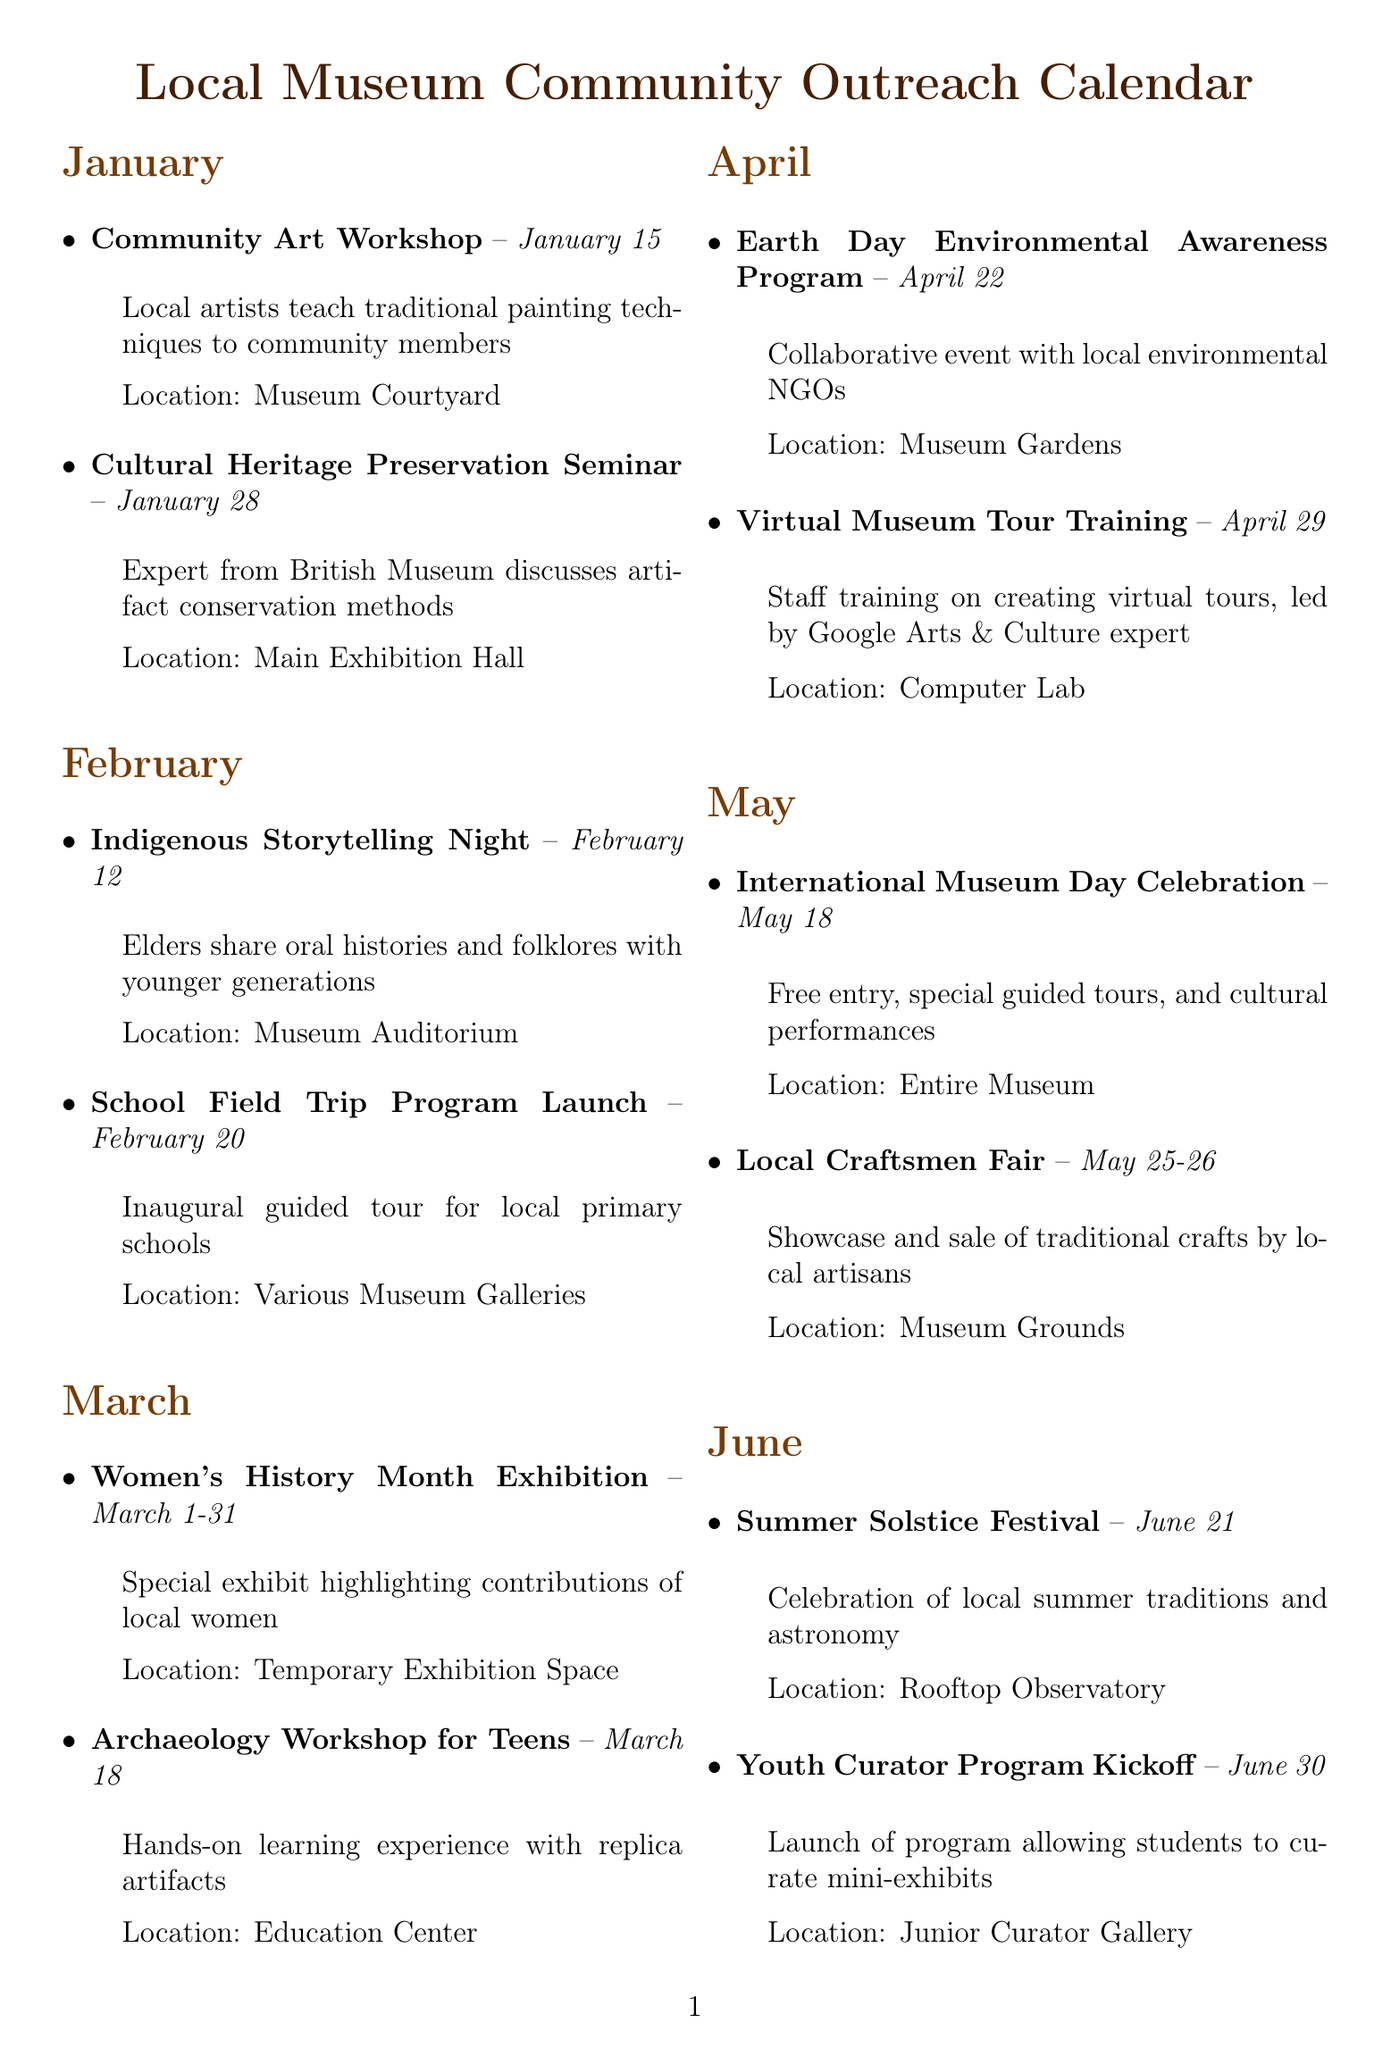What event occurs on February 12? The event on February 12 is Indigenous Storytelling Night, which involves elders sharing oral histories and folklores with younger generations.
Answer: Indigenous Storytelling Night What is the location of the Cultural Heritage Preservation Seminar? The location of the Cultural Heritage Preservation Seminar is in the Main Exhibition Hall.
Answer: Main Exhibition Hall How many events are scheduled for March? March has two events listed: Women's History Month Exhibition and Archaeology Workshop for Teens, thus the total is two events.
Answer: 2 When is the next major celebration after May? After May, the next major celebration is the Summer Solstice Festival on June 21.
Answer: June 21 Which month features a program aimed at local teens? The month of March features the Archaeology Workshop for Teens, aimed at providing hands-on learning experiences.
Answer: March What are the dates for the National Independence Day Exhibition? The National Independence Day Exhibition spans the entire month of July, from July 1 to July 31.
Answer: July 1-31 Which event allows families to participate in an educational overnight experience? The event allowing families to participate in an educational overnight experience is the Night at the Museum Sleepover on August 20.
Answer: Night at the Museum Sleepover What type of event is scheduled for October 15? The event scheduled for October 15 is a Digital Archiving Workshop aimed at training on digitizing museum collections.
Answer: Digital Archiving Workshop What topic is covered during the Earth Day program? The Earth Day Environmental Awareness Program focuses on environmental awareness in collaboration with local NGOs.
Answer: Environmental Awareness 